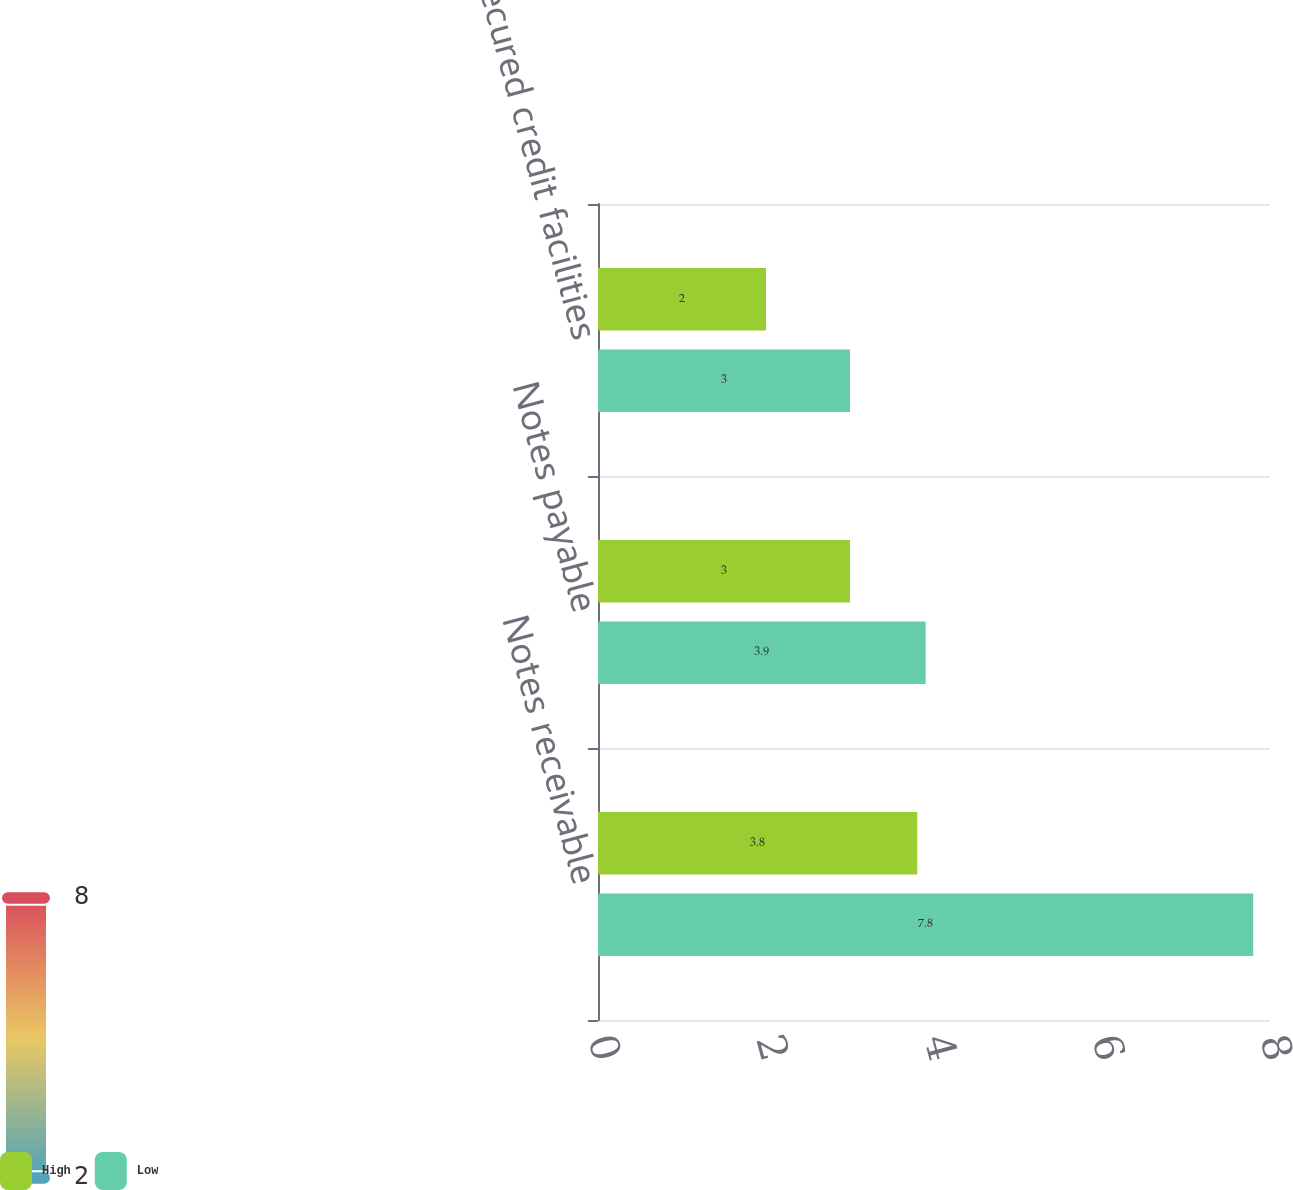Convert chart. <chart><loc_0><loc_0><loc_500><loc_500><stacked_bar_chart><ecel><fcel>Notes receivable<fcel>Notes payable<fcel>Unsecured credit facilities<nl><fcel>High<fcel>3.8<fcel>3<fcel>2<nl><fcel>Low<fcel>7.8<fcel>3.9<fcel>3<nl></chart> 